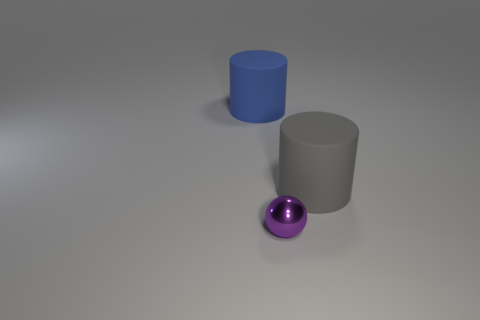Subtract all spheres. How many objects are left? 2 Subtract 2 cylinders. How many cylinders are left? 0 Add 2 big green rubber cubes. How many objects exist? 5 Add 2 gray objects. How many gray objects are left? 3 Add 3 big rubber things. How many big rubber things exist? 5 Subtract 0 blue balls. How many objects are left? 3 Subtract all purple cylinders. Subtract all red blocks. How many cylinders are left? 2 Subtract all blue cubes. How many yellow balls are left? 0 Subtract all big objects. Subtract all red spheres. How many objects are left? 1 